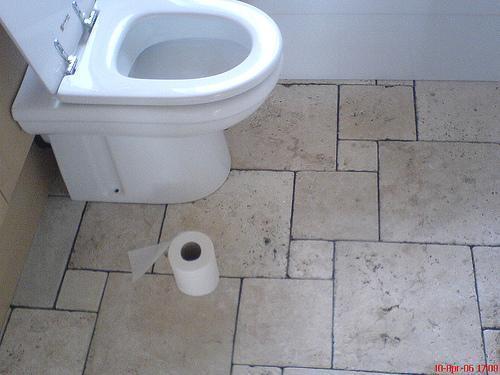How many rolls of toilet paper are there?
Give a very brief answer. 1. 